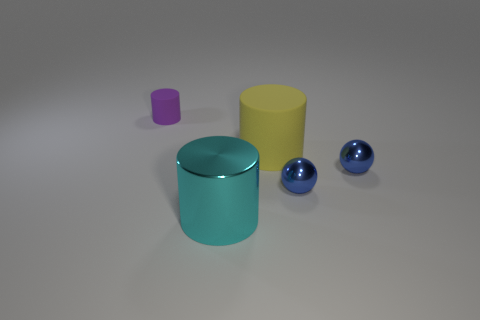Add 1 gray rubber blocks. How many objects exist? 6 Subtract all cylinders. How many objects are left? 2 Subtract 0 yellow balls. How many objects are left? 5 Subtract all metal blocks. Subtract all big rubber things. How many objects are left? 4 Add 3 tiny purple objects. How many tiny purple objects are left? 4 Add 2 cylinders. How many cylinders exist? 5 